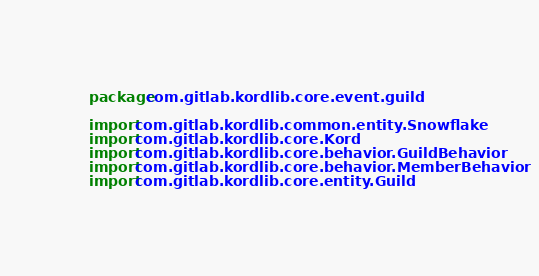<code> <loc_0><loc_0><loc_500><loc_500><_Kotlin_>package com.gitlab.kordlib.core.event.guild

import com.gitlab.kordlib.common.entity.Snowflake
import com.gitlab.kordlib.core.Kord
import com.gitlab.kordlib.core.behavior.GuildBehavior
import com.gitlab.kordlib.core.behavior.MemberBehavior
import com.gitlab.kordlib.core.entity.Guild</code> 